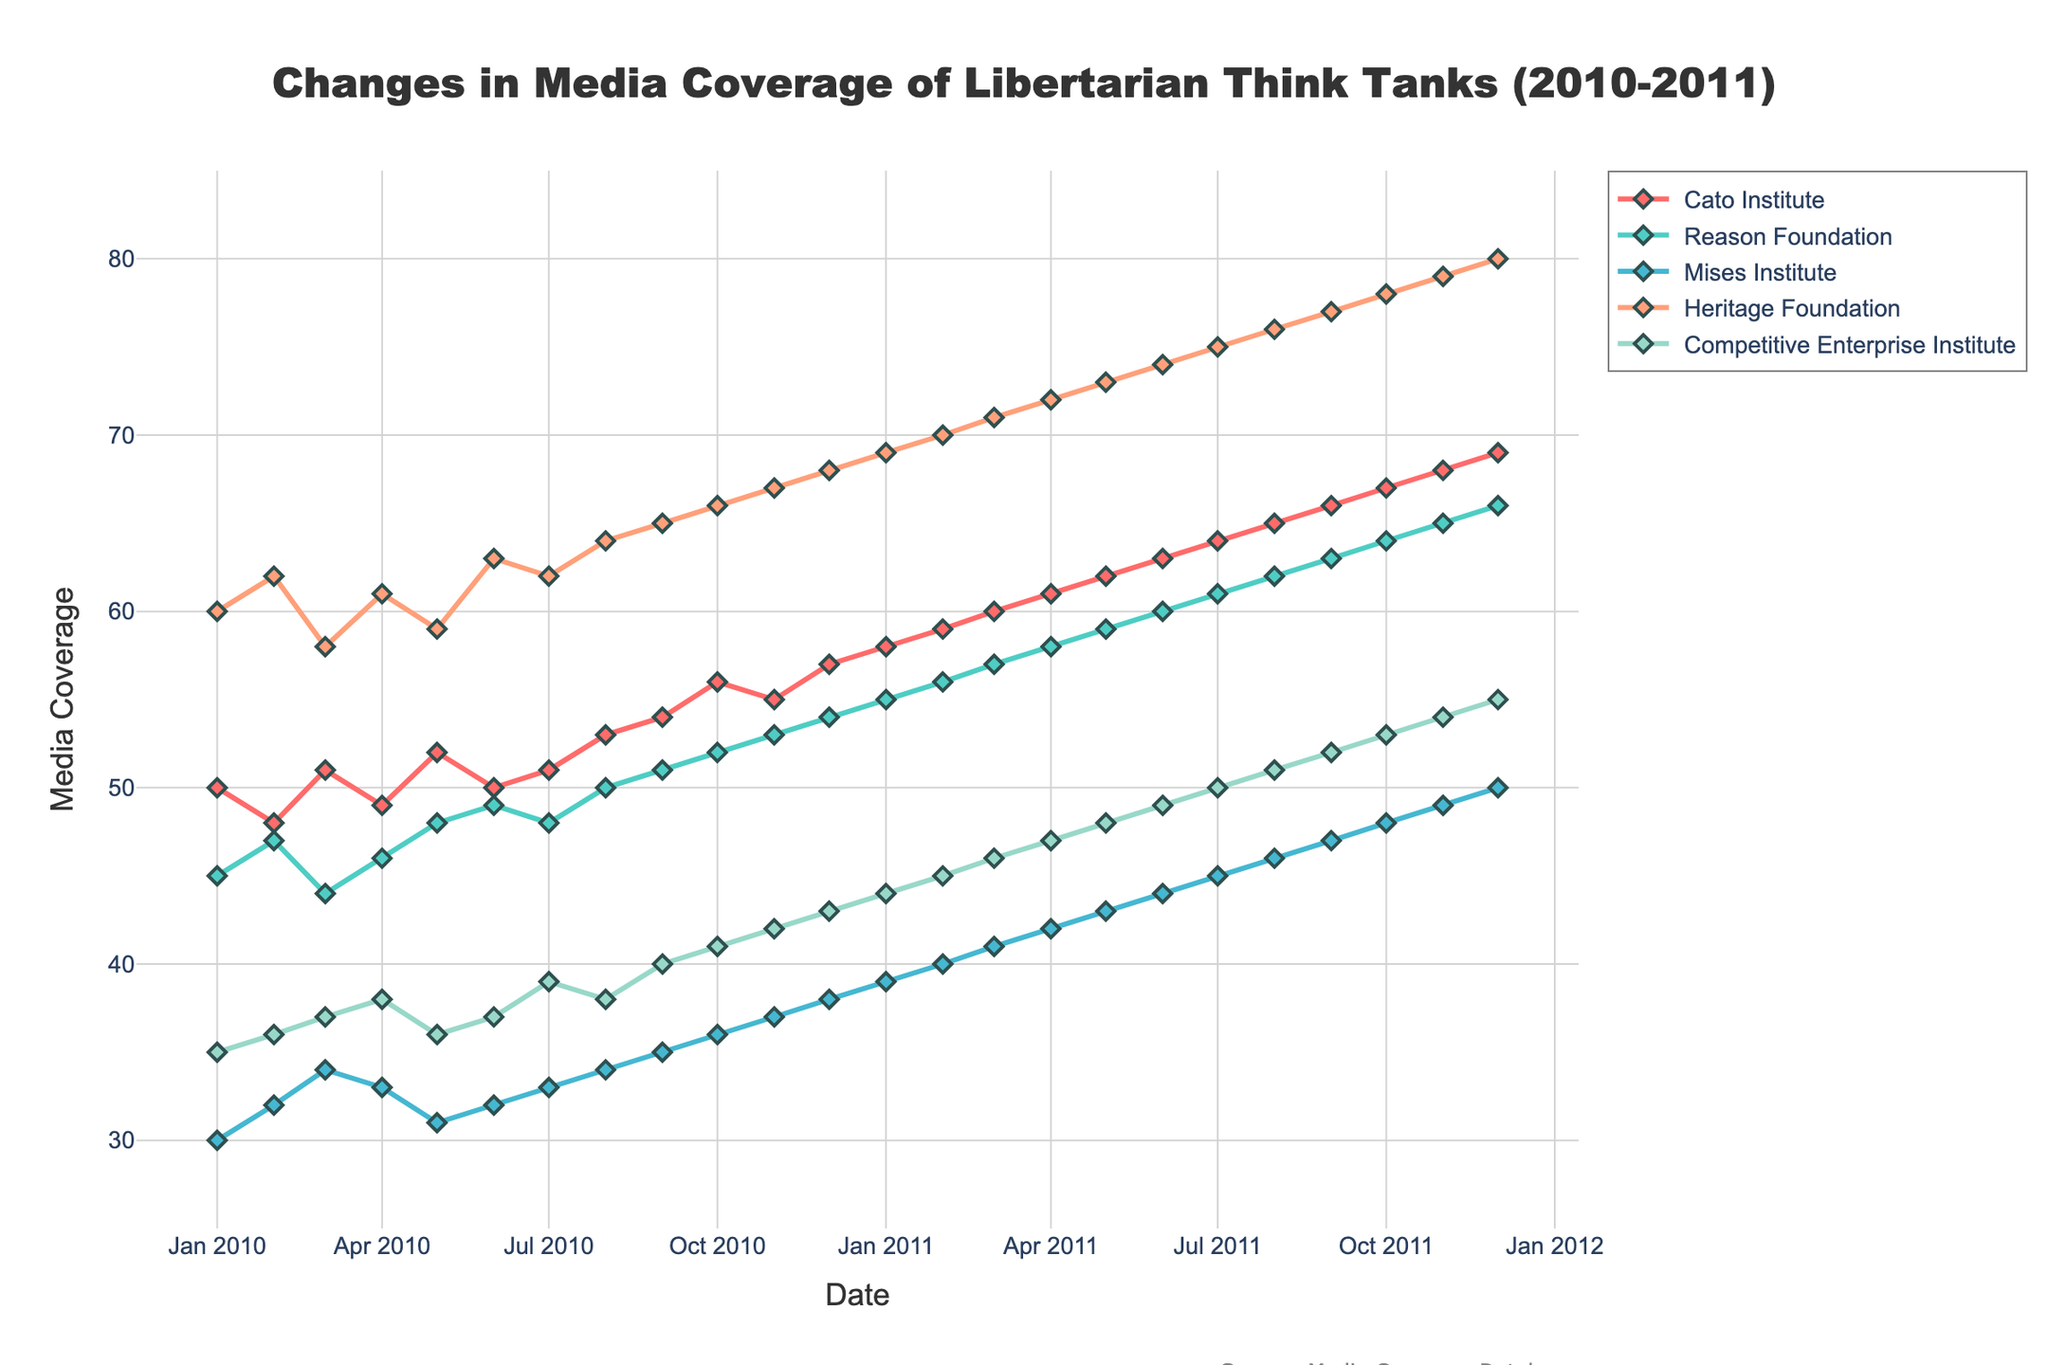What is the title of the plot? The title of the plot is typically located at the top and is displayed prominently. It helps to understand the overall context of the figure.
Answer: Changes in Media Coverage of Libertarian Think Tanks (2010-2011) Which think tank had the highest media coverage in January 2010? Looking at the first data point corresponding to January 2010 in the plot, compare the media coverage values for all think tanks. The think tank with the highest value is the one with the highest media coverage.
Answer: Heritage Foundation What is the general trend of the Cato Institute's media coverage over the time period? Observe the line representing the Cato Institute. Determine whether it is generally increasing, decreasing, or fluctuating over time. This trend can be observed by plotting the monthly media coverage values over the given timeframe.
Answer: Increasing What is the average media coverage of the Competitive Enterprise Institute over the entire period? Sum all the media coverage values for the Competitive Enterprise Institute and divide by the number of data points (months) to get the average.
Answer: (35+36+37+38+40+41+42+43+44+45+46+47+48+49+50+51+52+53+54+55)/(24 months) = 46.8 Which think tank showed the most significant increase in media coverage from January 2010 to December 2011? Calculate the difference in media coverage from January 2010 to December 2011 for each think tank. The think tank with the largest positive difference had the most significant increase.
Answer: Heritage Foundation By how many points did the media coverage of the Reason Foundation increase from May 2010 to December 2010? Subtract the media coverage value in May 2010 from the value in December 2010.
Answer: 54 - 48 = 6 In which month did the Mises Institute reach a media coverage of 50? Identify the data point where the Mises Institute's media coverage value is 50 and note the corresponding month.
Answer: December 2011 Compare the media coverage of the Cato Institute and the Heritage Foundation in August 2011. Which one was higher, and by how much? Look at the media coverage values for both think tanks in August 2011. Subtract the value of the Cato Institute from the Heritage Foundation to find the difference.
Answer: Heritage Foundation was higher by (76 - 65) = 11 points Did any think tank experience a decrease in media coverage in the timeframe, and if so, which one? Examine the trend lines for each think tank over the given period. Identify any think tank(s) with a downward trend in their media coverage.
Answer: No What is the media coverage difference between the highest and lowest think tanks in December 2011? Identify the media coverage values for all think tanks in December 2011. Find the highest and lowest values and subtract the lowest from the highest.
Answer: 80 - 55 = 25 